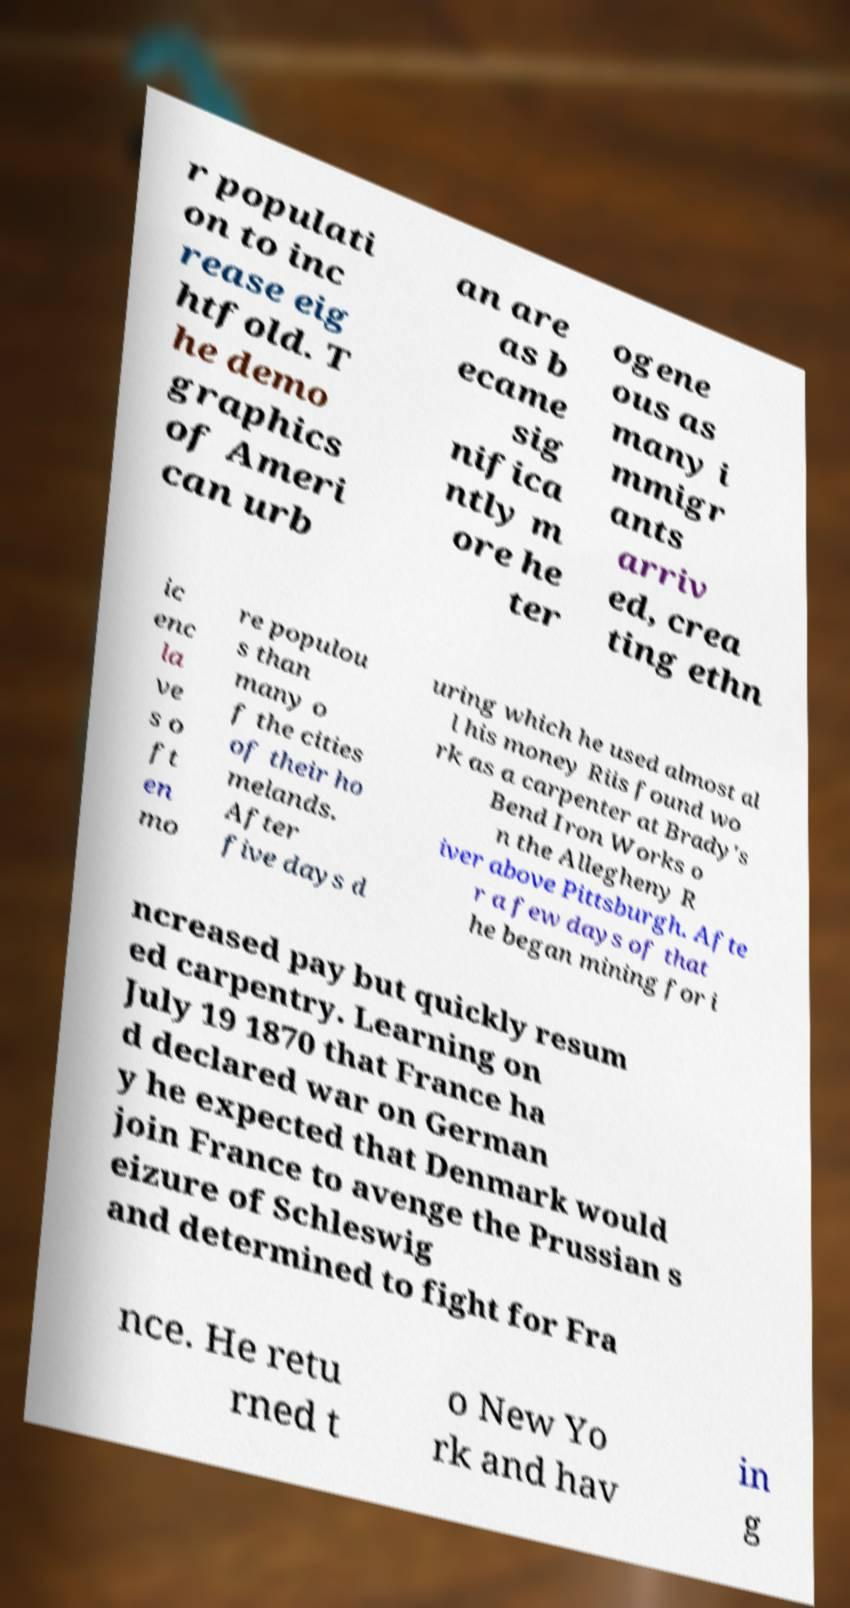There's text embedded in this image that I need extracted. Can you transcribe it verbatim? r populati on to inc rease eig htfold. T he demo graphics of Ameri can urb an are as b ecame sig nifica ntly m ore he ter ogene ous as many i mmigr ants arriv ed, crea ting ethn ic enc la ve s o ft en mo re populou s than many o f the cities of their ho melands. After five days d uring which he used almost al l his money Riis found wo rk as a carpenter at Brady's Bend Iron Works o n the Allegheny R iver above Pittsburgh. Afte r a few days of that he began mining for i ncreased pay but quickly resum ed carpentry. Learning on July 19 1870 that France ha d declared war on German y he expected that Denmark would join France to avenge the Prussian s eizure of Schleswig and determined to fight for Fra nce. He retu rned t o New Yo rk and hav in g 